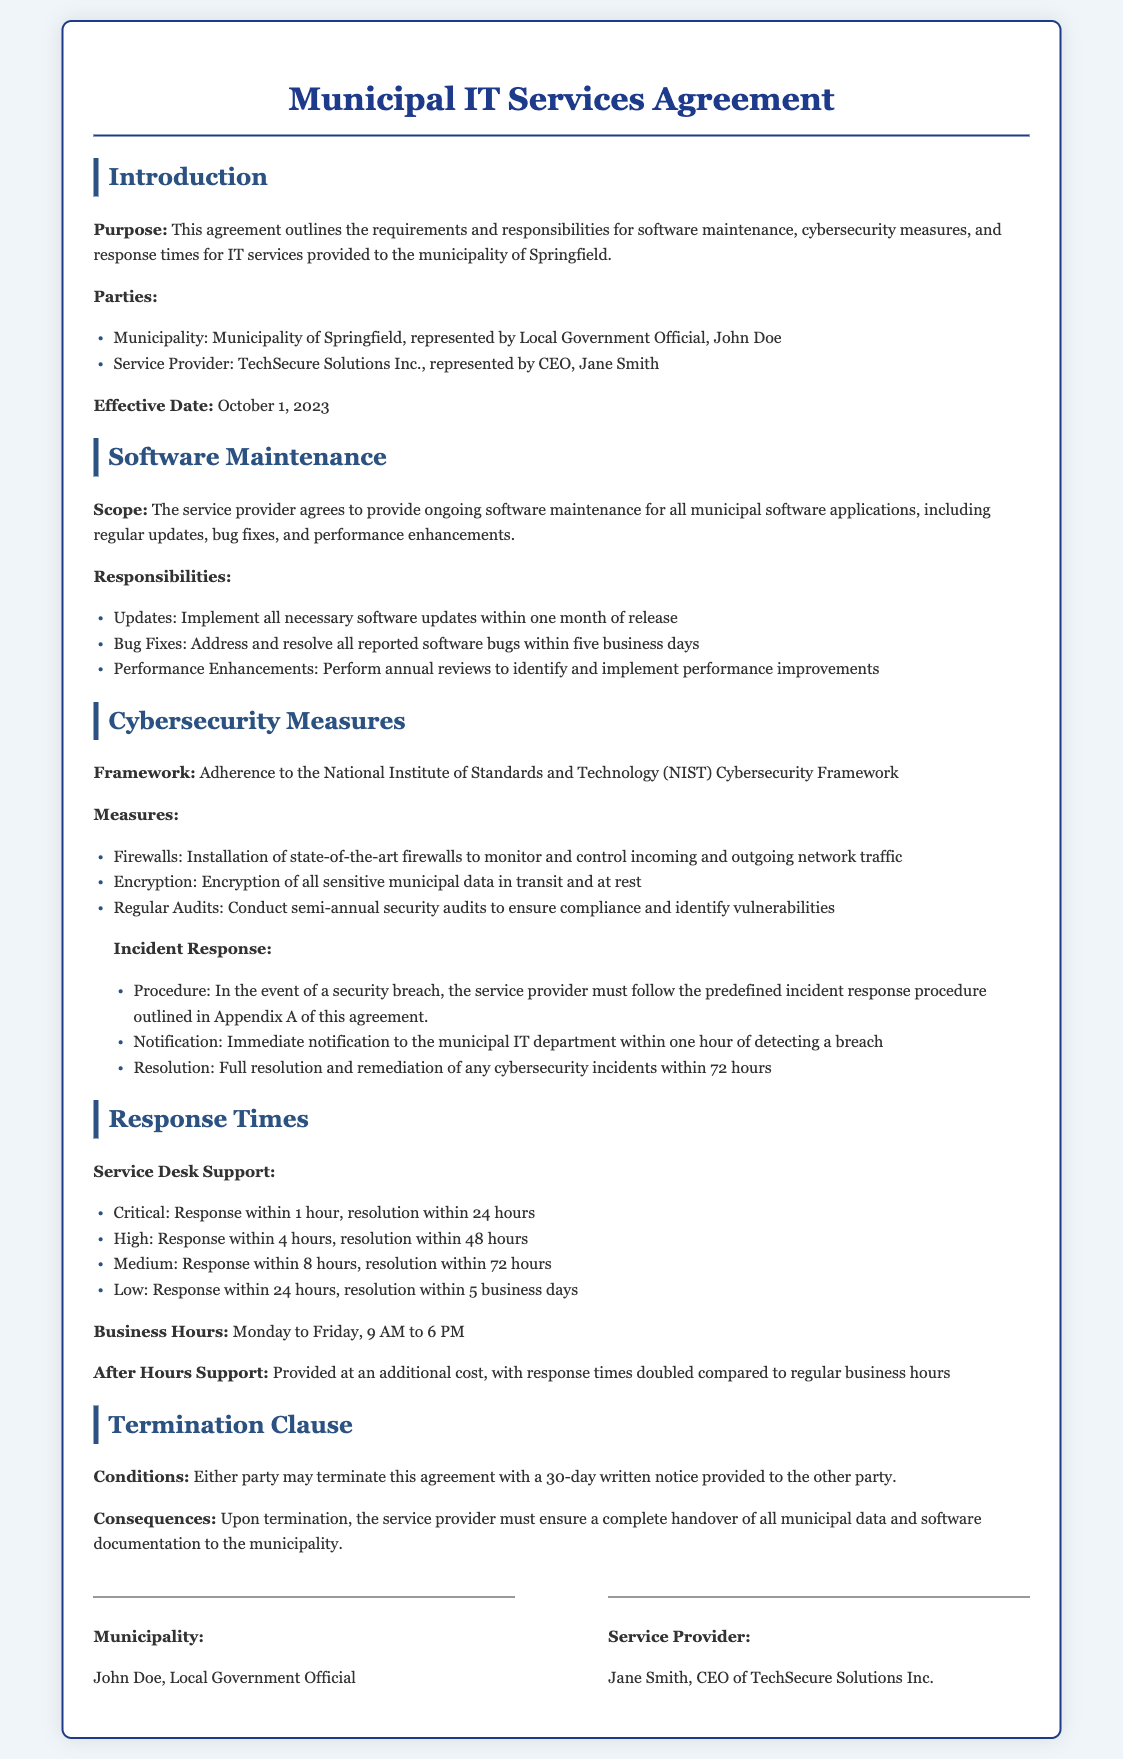What is the purpose of this agreement? The purpose of this agreement is to outline the requirements and responsibilities for software maintenance, cybersecurity measures, and response times for IT services provided to the municipality of Springfield.
Answer: To outline software maintenance, cybersecurity measures, and response times Who represents the Municipality of Springfield? The document states that John Doe represents the Municipality of Springfield.
Answer: John Doe What is the effective date of this agreement? The effective date is explicitly mentioned in the document as October 1, 2023.
Answer: October 1, 2023 What is the maximum time to address reported software bugs? The agreed time to address reported software bugs is stated as five business days in the document.
Answer: five business days What are the response times for critical support? The document specifies that for critical support, the response time is within 1 hour and resolution within 24 hours.
Answer: Response within 1 hour, resolution within 24 hours What framework must cybersecurity measures adhere to? The document mandates adherence to the National Institute of Standards and Technology (NIST) Cybersecurity Framework.
Answer: NIST Cybersecurity Framework What is the notification time frame for a security breach? The service provider must notify the municipal IT department within one hour of detecting a breach.
Answer: one hour What is the period for semi-annual security audits? The requirement for semi-annual security audits is indicated as occurring every six months, ensuring compliance and identifying vulnerabilities.
Answer: semi-annual What happens upon termination of the agreement? Upon termination, the service provider must ensure a complete handover of all municipal data and software documentation.
Answer: Complete handover of all municipal data and software documentation 